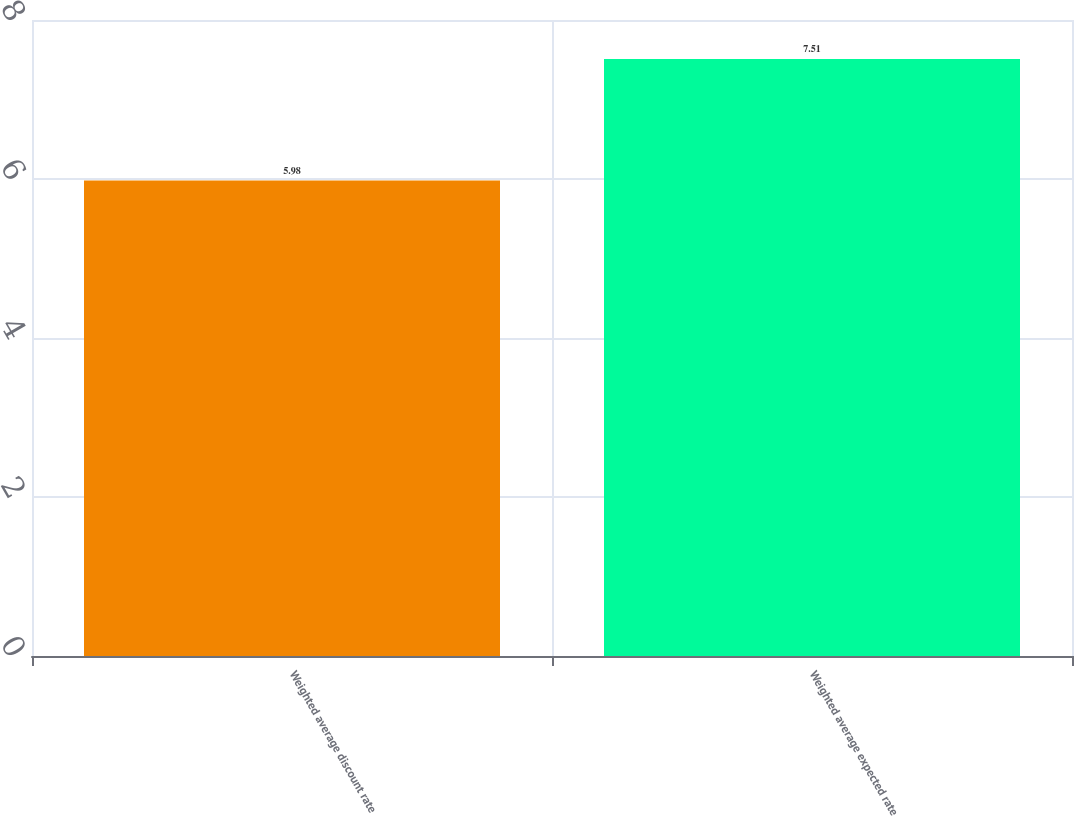<chart> <loc_0><loc_0><loc_500><loc_500><bar_chart><fcel>Weighted average discount rate<fcel>Weighted average expected rate<nl><fcel>5.98<fcel>7.51<nl></chart> 